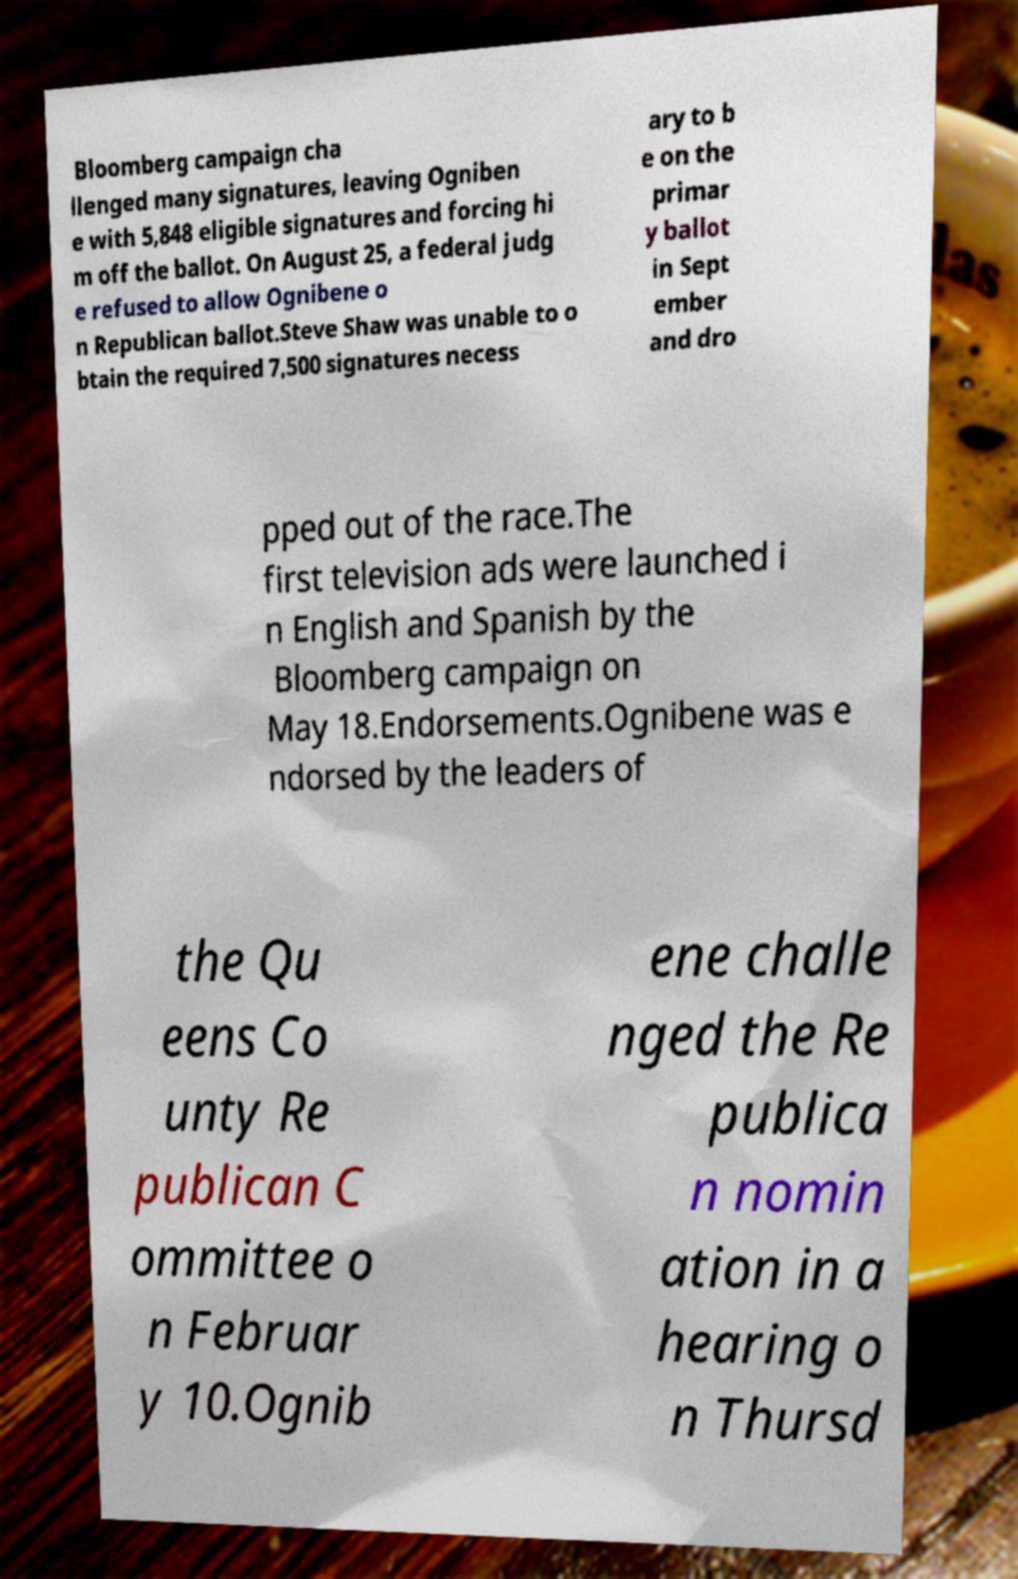I need the written content from this picture converted into text. Can you do that? Bloomberg campaign cha llenged many signatures, leaving Ogniben e with 5,848 eligible signatures and forcing hi m off the ballot. On August 25, a federal judg e refused to allow Ognibene o n Republican ballot.Steve Shaw was unable to o btain the required 7,500 signatures necess ary to b e on the primar y ballot in Sept ember and dro pped out of the race.The first television ads were launched i n English and Spanish by the Bloomberg campaign on May 18.Endorsements.Ognibene was e ndorsed by the leaders of the Qu eens Co unty Re publican C ommittee o n Februar y 10.Ognib ene challe nged the Re publica n nomin ation in a hearing o n Thursd 